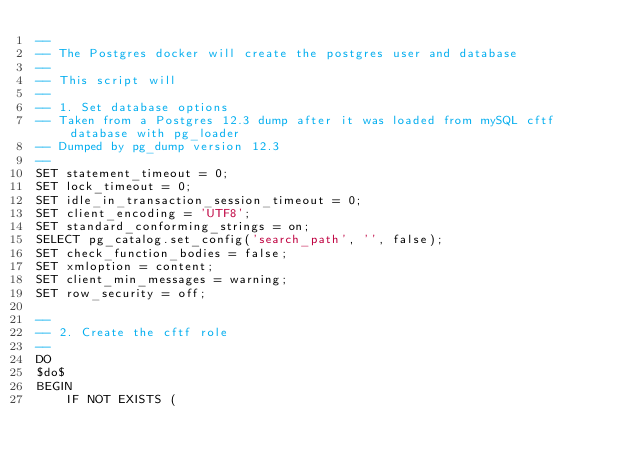<code> <loc_0><loc_0><loc_500><loc_500><_SQL_>--
-- The Postgres docker will create the postgres user and database
--
-- This script will
--
-- 1. Set database options
-- Taken from a Postgres 12.3 dump after it was loaded from mySQL cftf database with pg_loader
-- Dumped by pg_dump version 12.3
--
SET statement_timeout = 0;
SET lock_timeout = 0;
SET idle_in_transaction_session_timeout = 0;
SET client_encoding = 'UTF8';
SET standard_conforming_strings = on;
SELECT pg_catalog.set_config('search_path', '', false);
SET check_function_bodies = false;
SET xmloption = content;
SET client_min_messages = warning;
SET row_security = off;

--
-- 2. Create the cftf role
--
DO
$do$
BEGIN
    IF NOT EXISTS (</code> 